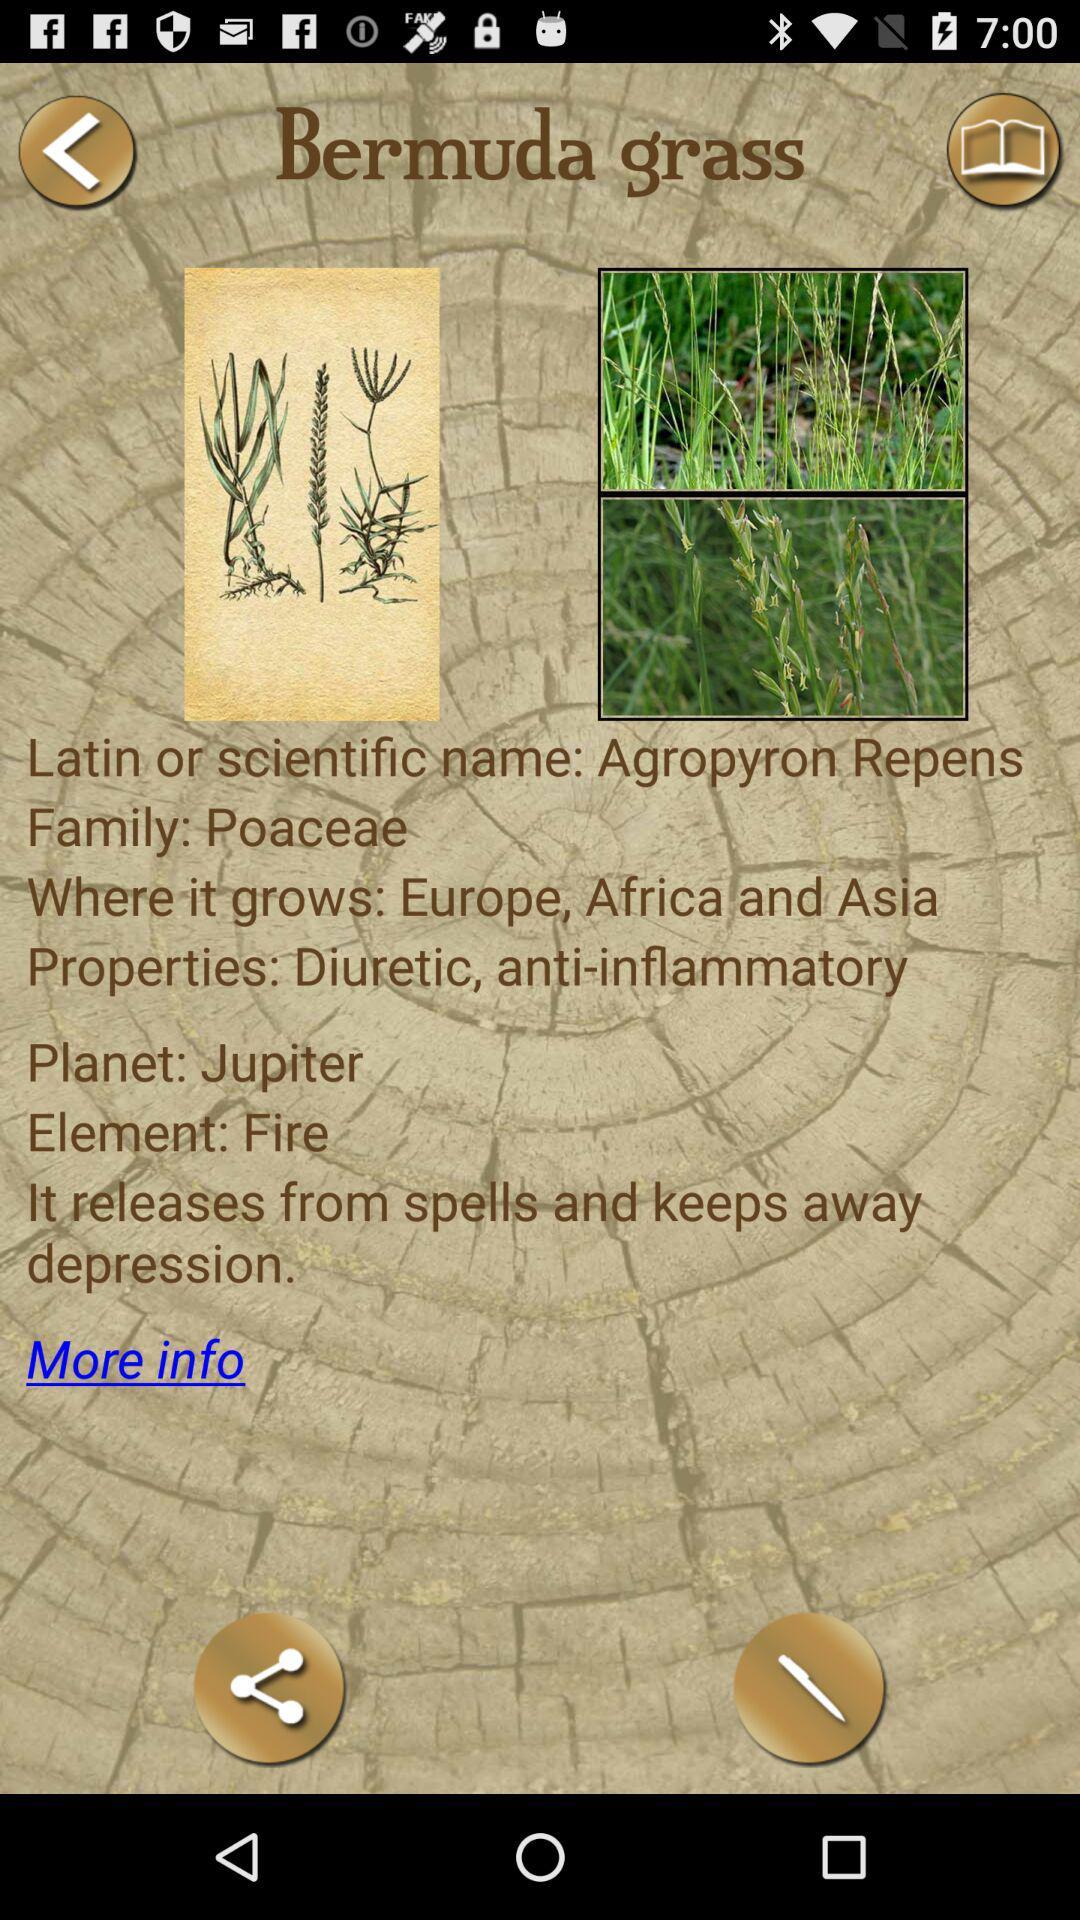In what countries does Bermuda grass grow? The countries are Europe, Africa, and Asia. 